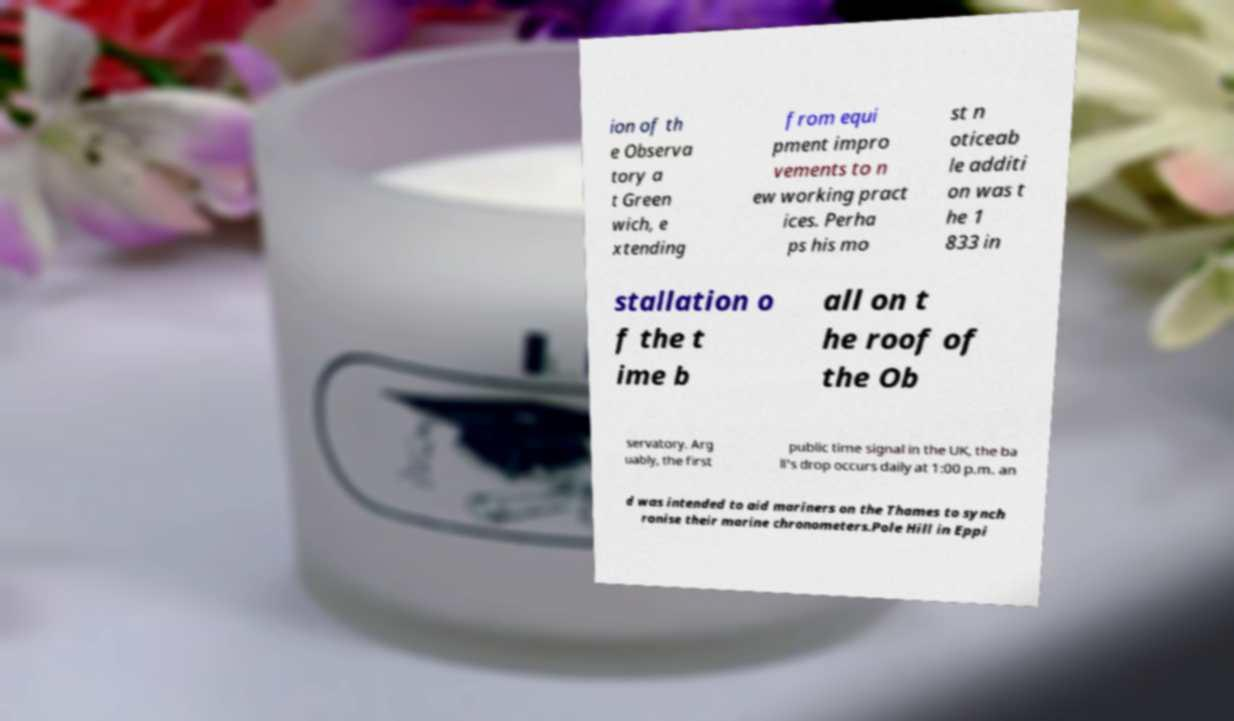Could you assist in decoding the text presented in this image and type it out clearly? ion of th e Observa tory a t Green wich, e xtending from equi pment impro vements to n ew working pract ices. Perha ps his mo st n oticeab le additi on was t he 1 833 in stallation o f the t ime b all on t he roof of the Ob servatory. Arg uably, the first public time signal in the UK, the ba ll's drop occurs daily at 1:00 p.m. an d was intended to aid mariners on the Thames to synch ronise their marine chronometers.Pole Hill in Eppi 